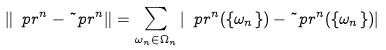<formula> <loc_0><loc_0><loc_500><loc_500>\left \| \ p r ^ { n } - \tilde { \ } p r ^ { n } \right \| = \sum _ { \omega _ { n } \in \Omega _ { n } } \left | \ p r ^ { n } ( \{ \omega _ { n } \} ) - \tilde { \ } p r ^ { n } ( \{ \omega _ { n } \} ) \right |</formula> 